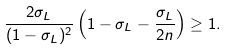Convert formula to latex. <formula><loc_0><loc_0><loc_500><loc_500>\frac { 2 \sigma _ { L } } { ( 1 - \sigma _ { L } ) ^ { 2 } } \left ( 1 - \sigma _ { L } - \frac { \sigma _ { L } } { 2 n } \right ) \geq 1 .</formula> 